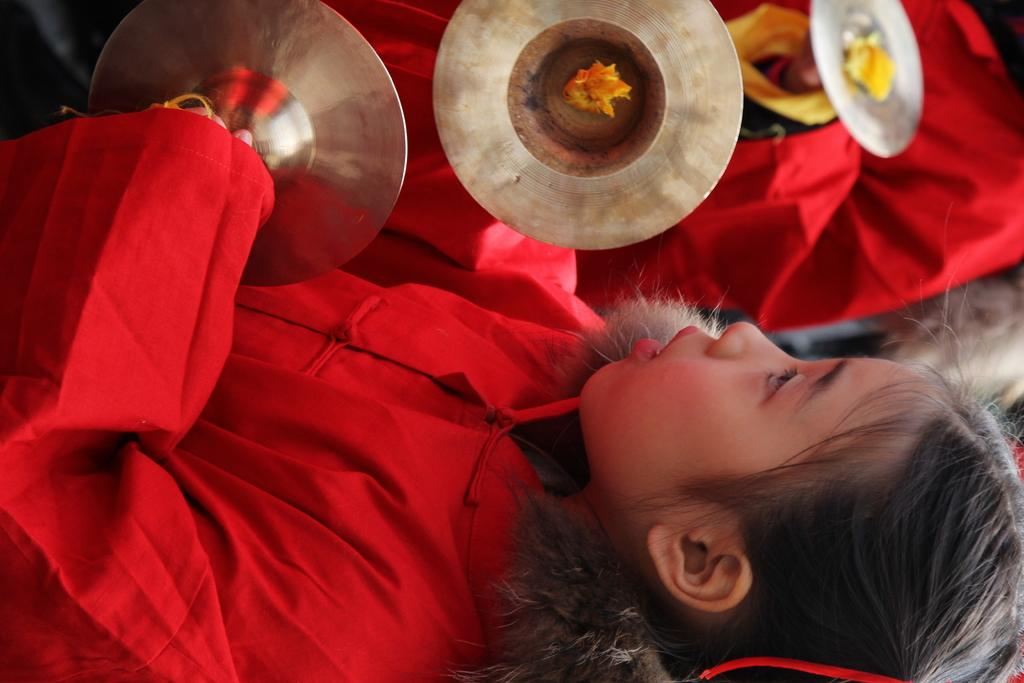How many people are in the image? There are people in the image, but the exact number is not specified. What can be observed about the clothing of some of the people? Some of the people are wearing red color clothes. Can you describe the position of the girl in the image? The girl is in the front of the image. What is the girl holding in her hands? The girl is holding musical instruments in her hands. How many cents are visible in the image? There are no cents present in the image. 